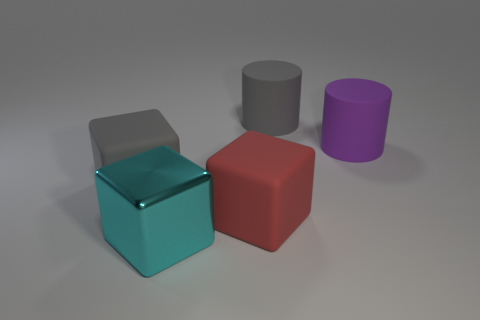Add 1 purple objects. How many objects exist? 6 Subtract all cyan shiny blocks. How many blocks are left? 2 Subtract 1 cylinders. How many cylinders are left? 1 Subtract all cyan blocks. How many blocks are left? 2 Subtract all cyan cubes. Subtract all gray spheres. How many cubes are left? 2 Subtract all purple objects. Subtract all big gray rubber things. How many objects are left? 2 Add 4 red rubber blocks. How many red rubber blocks are left? 5 Add 4 small yellow matte cylinders. How many small yellow matte cylinders exist? 4 Subtract 1 red cubes. How many objects are left? 4 Subtract all cylinders. How many objects are left? 3 